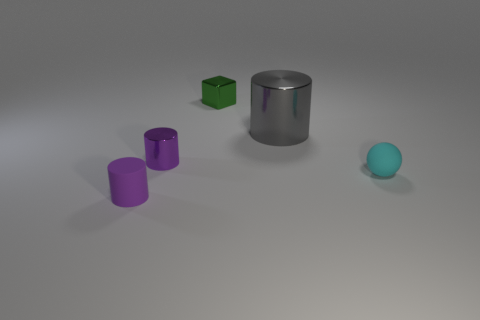Subtract all gray blocks. How many purple cylinders are left? 2 Add 1 small purple metal things. How many objects exist? 6 Subtract all cubes. How many objects are left? 4 Add 5 shiny cubes. How many shiny cubes are left? 6 Add 5 blue matte things. How many blue matte things exist? 5 Subtract 0 purple balls. How many objects are left? 5 Subtract all green blocks. Subtract all green cubes. How many objects are left? 3 